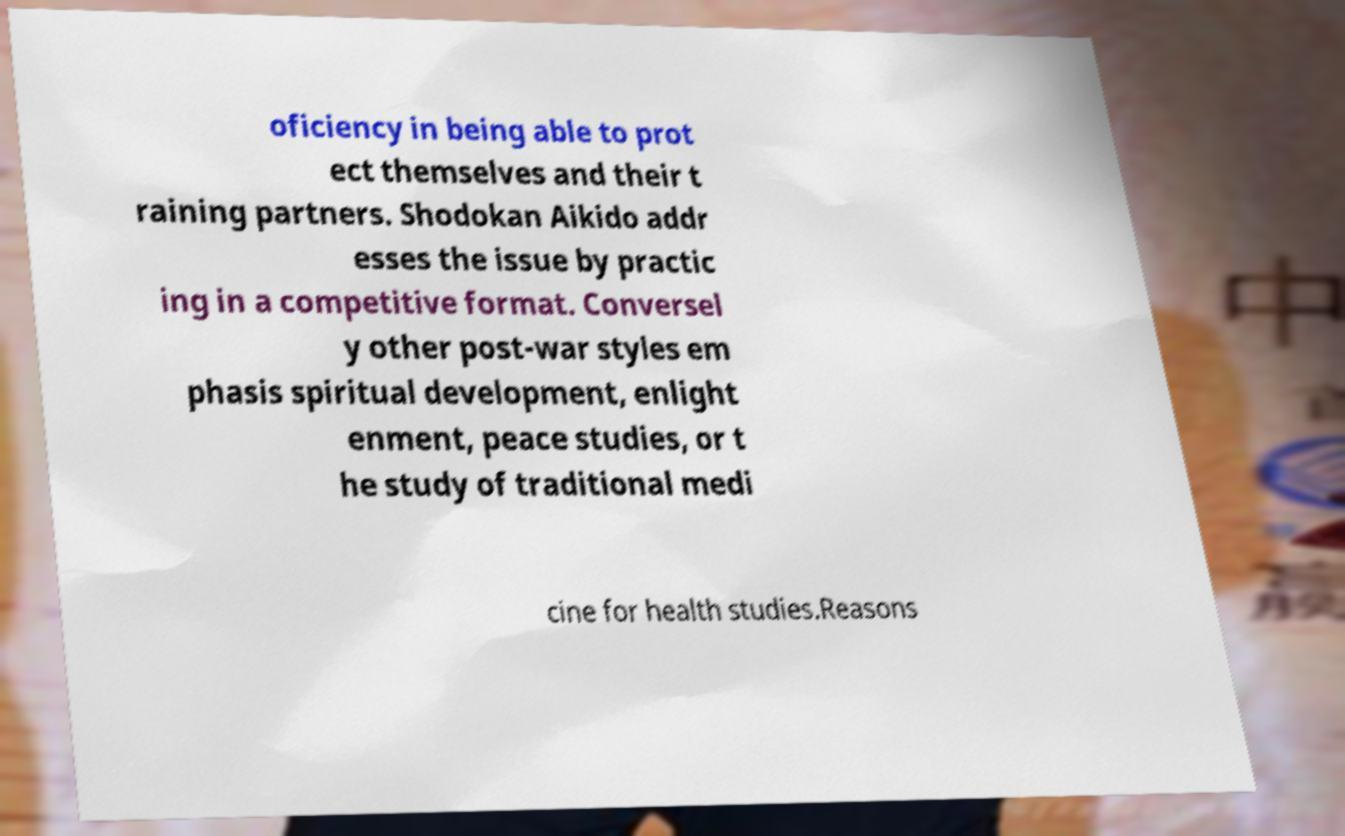Could you extract and type out the text from this image? oficiency in being able to prot ect themselves and their t raining partners. Shodokan Aikido addr esses the issue by practic ing in a competitive format. Conversel y other post-war styles em phasis spiritual development, enlight enment, peace studies, or t he study of traditional medi cine for health studies.Reasons 